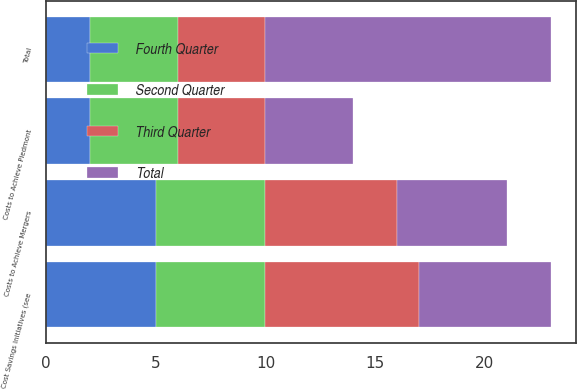Convert chart. <chart><loc_0><loc_0><loc_500><loc_500><stacked_bar_chart><ecel><fcel>Costs to Achieve Piedmont<fcel>Total<fcel>Costs to Achieve Mergers<fcel>Cost Savings Initiatives (see<nl><fcel>Fourth Quarter<fcel>2<fcel>2<fcel>5<fcel>5<nl><fcel>Second Quarter<fcel>4<fcel>4<fcel>5<fcel>5<nl><fcel>Third Quarter<fcel>4<fcel>4<fcel>6<fcel>7<nl><fcel>Total<fcel>4<fcel>13<fcel>5<fcel>6<nl></chart> 